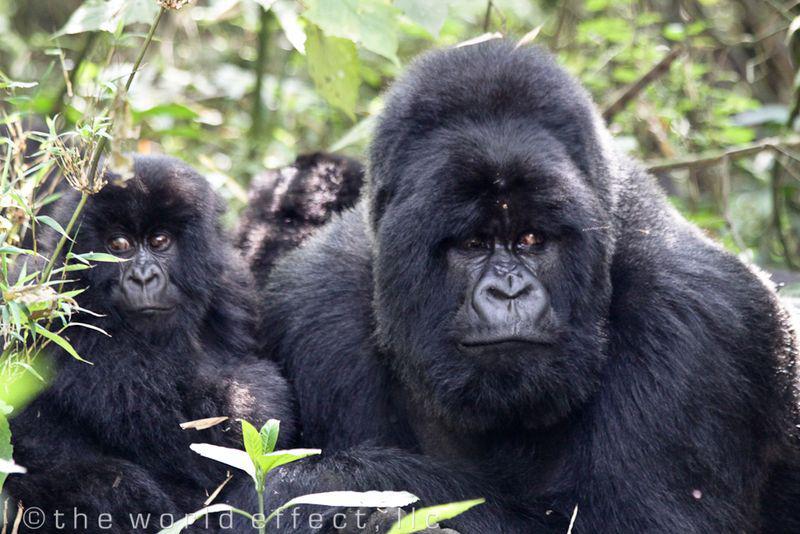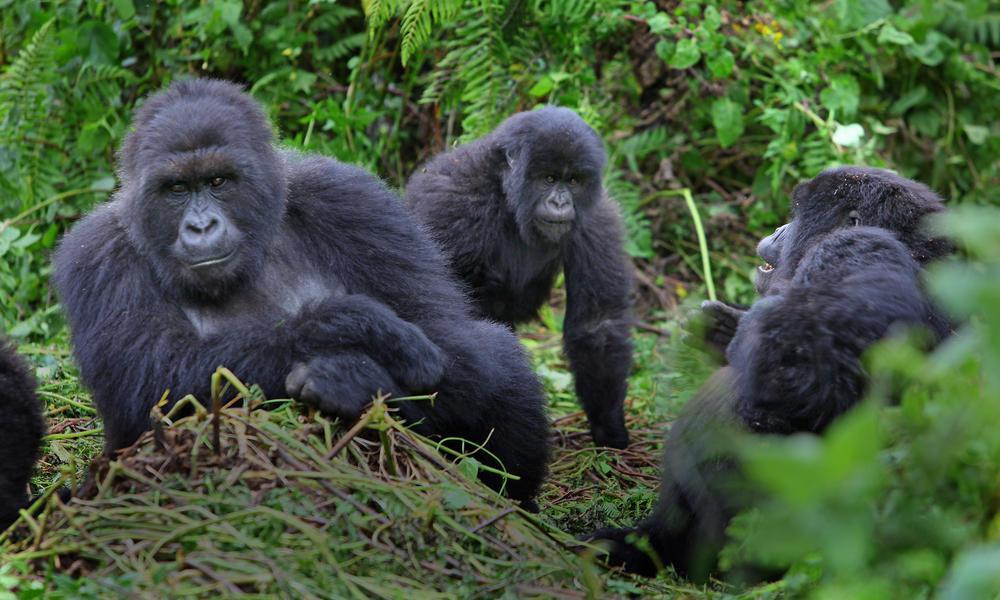The first image is the image on the left, the second image is the image on the right. For the images shown, is this caption "The right image shows curled gray fingers pointing toward the head of a forward-facing baby gorilla." true? Answer yes or no. No. 